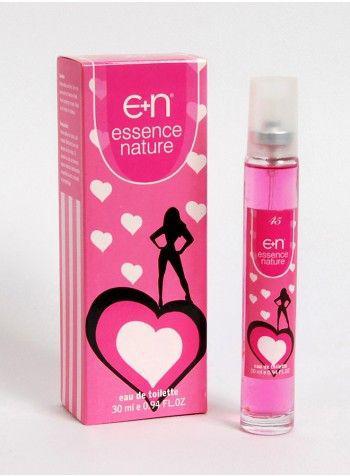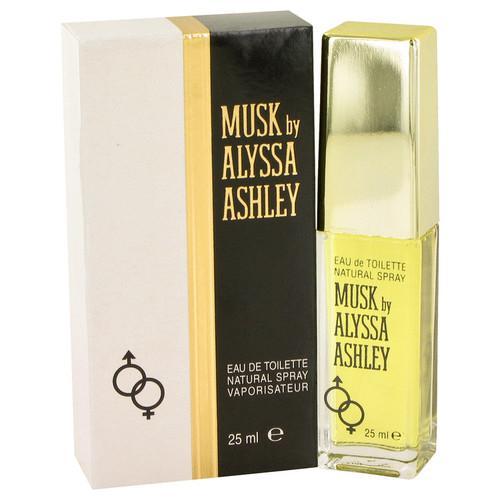The first image is the image on the left, the second image is the image on the right. Given the left and right images, does the statement "A pink perfume bottle is next to its box in the left image." hold true? Answer yes or no. Yes. The first image is the image on the left, the second image is the image on the right. Analyze the images presented: Is the assertion "An image shows a product with a galloping horse on the front of the package." valid? Answer yes or no. No. 